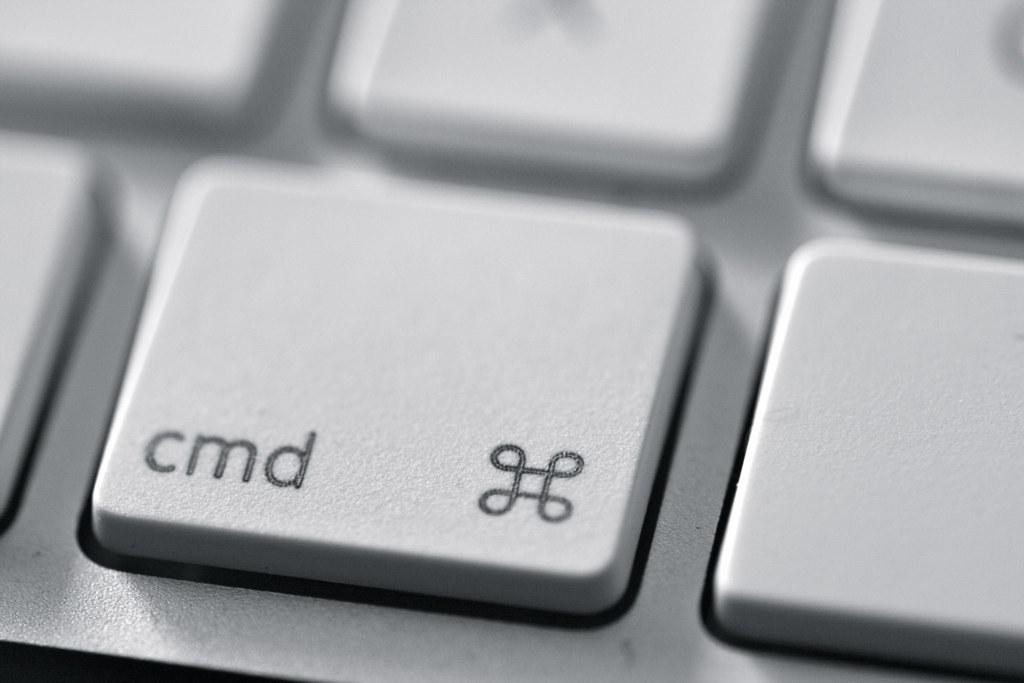<image>
Create a compact narrative representing the image presented. cmd key next to a symbol on a computer laptop. 